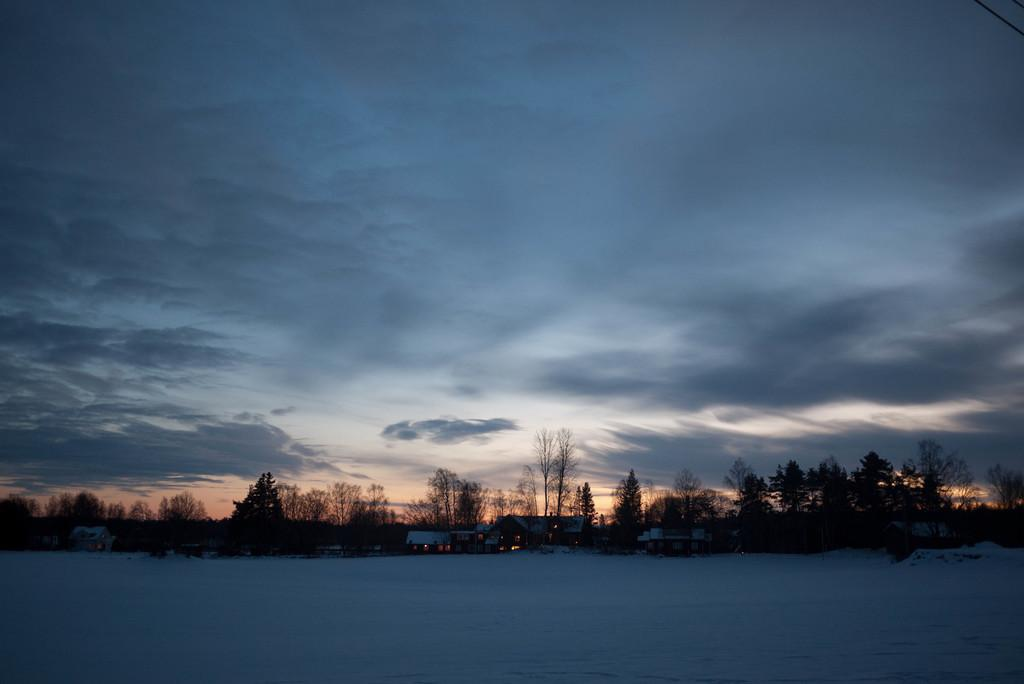What type of vegetation can be seen in the image? There are trees in the image. What type of structures are present in the image? There are sheds in the image. What can be seen illuminating the area in the image? There are lights visible in the image. What is covering the ground at the bottom of the image? There is snow at the bottom of the image. What is visible in the sky at the top of the image? There are clouds in the sky at the top of the image. What type of advertisement can be seen on the trees in the image? There are no advertisements present on the trees in the image; only trees, sheds, lights, snow, and clouds are visible. How many legs are visible in the image? There are no legs visible in the image; the focus is on the trees, sheds, lights, snow, and clouds. 